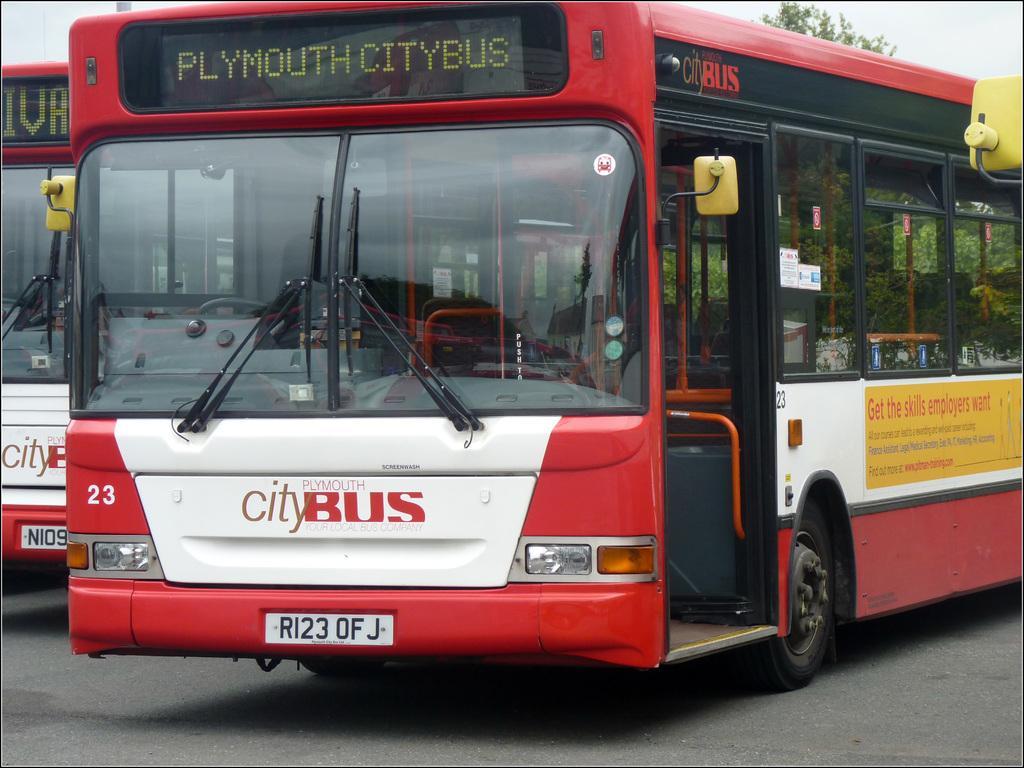Please provide a concise description of this image. There are two buses in red and white color combination on the road. In the background, there is a tree and there is sky. 